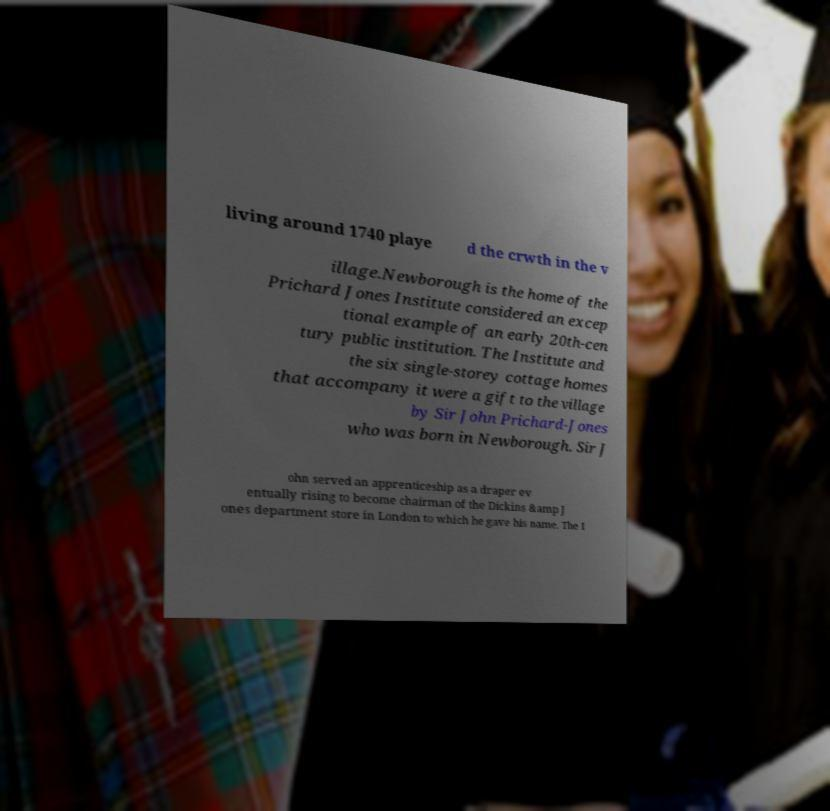Can you accurately transcribe the text from the provided image for me? living around 1740 playe d the crwth in the v illage.Newborough is the home of the Prichard Jones Institute considered an excep tional example of an early 20th-cen tury public institution. The Institute and the six single-storey cottage homes that accompany it were a gift to the village by Sir John Prichard-Jones who was born in Newborough. Sir J ohn served an apprenticeship as a draper ev entually rising to become chairman of the Dickins &amp J ones department store in London to which he gave his name. The I 